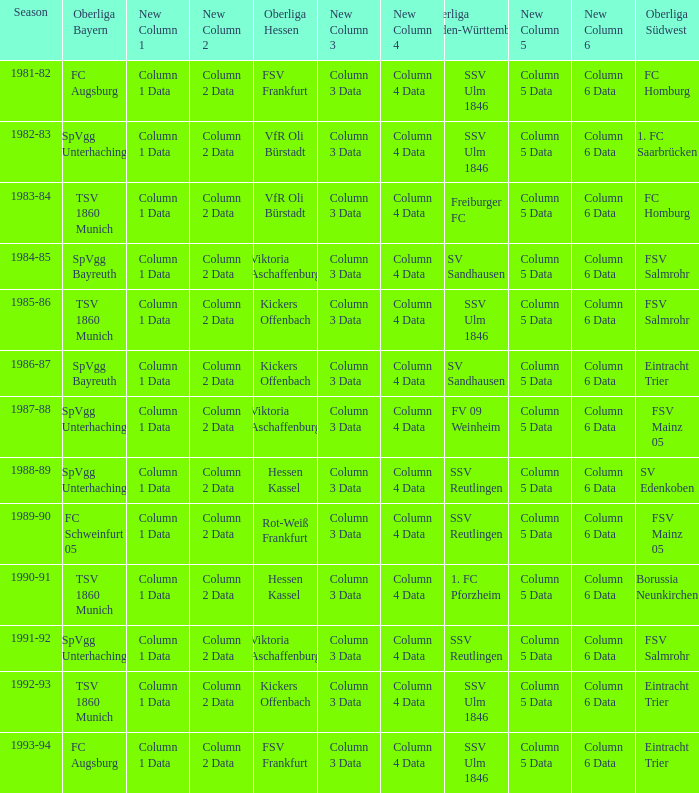Which Oberliga Bayern has a Season of 1981-82? FC Augsburg. 